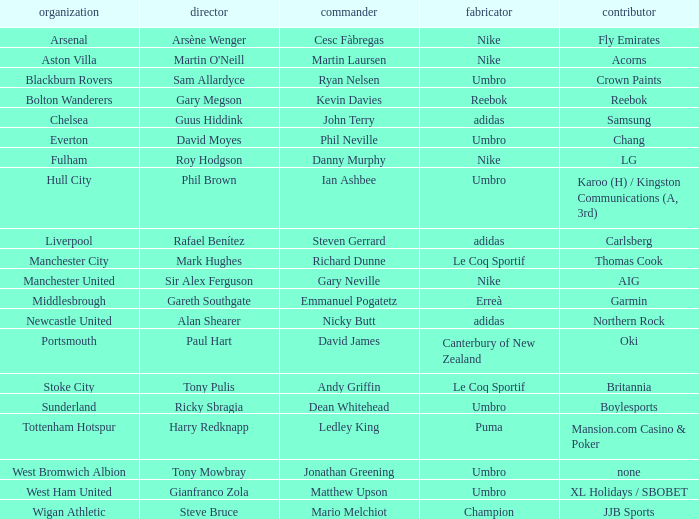What Premier League Manager has an Adidas sponsor and a Newcastle United club? Alan Shearer. Parse the full table. {'header': ['organization', 'director', 'commander', 'fabricator', 'contributor'], 'rows': [['Arsenal', 'Arsène Wenger', 'Cesc Fàbregas', 'Nike', 'Fly Emirates'], ['Aston Villa', "Martin O'Neill", 'Martin Laursen', 'Nike', 'Acorns'], ['Blackburn Rovers', 'Sam Allardyce', 'Ryan Nelsen', 'Umbro', 'Crown Paints'], ['Bolton Wanderers', 'Gary Megson', 'Kevin Davies', 'Reebok', 'Reebok'], ['Chelsea', 'Guus Hiddink', 'John Terry', 'adidas', 'Samsung'], ['Everton', 'David Moyes', 'Phil Neville', 'Umbro', 'Chang'], ['Fulham', 'Roy Hodgson', 'Danny Murphy', 'Nike', 'LG'], ['Hull City', 'Phil Brown', 'Ian Ashbee', 'Umbro', 'Karoo (H) / Kingston Communications (A, 3rd)'], ['Liverpool', 'Rafael Benítez', 'Steven Gerrard', 'adidas', 'Carlsberg'], ['Manchester City', 'Mark Hughes', 'Richard Dunne', 'Le Coq Sportif', 'Thomas Cook'], ['Manchester United', 'Sir Alex Ferguson', 'Gary Neville', 'Nike', 'AIG'], ['Middlesbrough', 'Gareth Southgate', 'Emmanuel Pogatetz', 'Erreà', 'Garmin'], ['Newcastle United', 'Alan Shearer', 'Nicky Butt', 'adidas', 'Northern Rock'], ['Portsmouth', 'Paul Hart', 'David James', 'Canterbury of New Zealand', 'Oki'], ['Stoke City', 'Tony Pulis', 'Andy Griffin', 'Le Coq Sportif', 'Britannia'], ['Sunderland', 'Ricky Sbragia', 'Dean Whitehead', 'Umbro', 'Boylesports'], ['Tottenham Hotspur', 'Harry Redknapp', 'Ledley King', 'Puma', 'Mansion.com Casino & Poker'], ['West Bromwich Albion', 'Tony Mowbray', 'Jonathan Greening', 'Umbro', 'none'], ['West Ham United', 'Gianfranco Zola', 'Matthew Upson', 'Umbro', 'XL Holidays / SBOBET'], ['Wigan Athletic', 'Steve Bruce', 'Mario Melchiot', 'Champion', 'JJB Sports']]} 